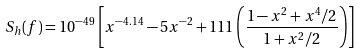Convert formula to latex. <formula><loc_0><loc_0><loc_500><loc_500>S _ { h } ( f ) = 1 0 ^ { - 4 9 } \left [ x ^ { - 4 . 1 4 } - 5 x ^ { - 2 } + 1 1 1 \left ( \frac { 1 - x ^ { 2 } + x ^ { 4 } / 2 } { 1 + x ^ { 2 } / 2 } \right ) \right ]</formula> 